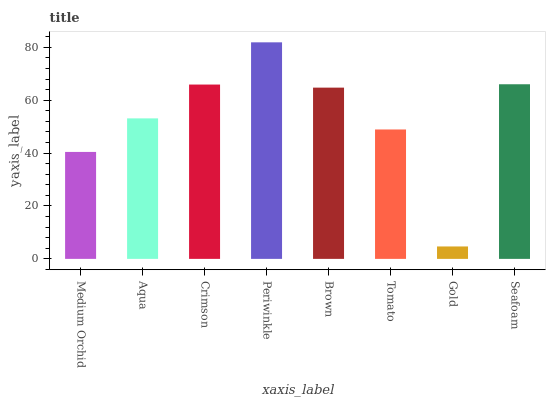Is Gold the minimum?
Answer yes or no. Yes. Is Periwinkle the maximum?
Answer yes or no. Yes. Is Aqua the minimum?
Answer yes or no. No. Is Aqua the maximum?
Answer yes or no. No. Is Aqua greater than Medium Orchid?
Answer yes or no. Yes. Is Medium Orchid less than Aqua?
Answer yes or no. Yes. Is Medium Orchid greater than Aqua?
Answer yes or no. No. Is Aqua less than Medium Orchid?
Answer yes or no. No. Is Brown the high median?
Answer yes or no. Yes. Is Aqua the low median?
Answer yes or no. Yes. Is Gold the high median?
Answer yes or no. No. Is Periwinkle the low median?
Answer yes or no. No. 